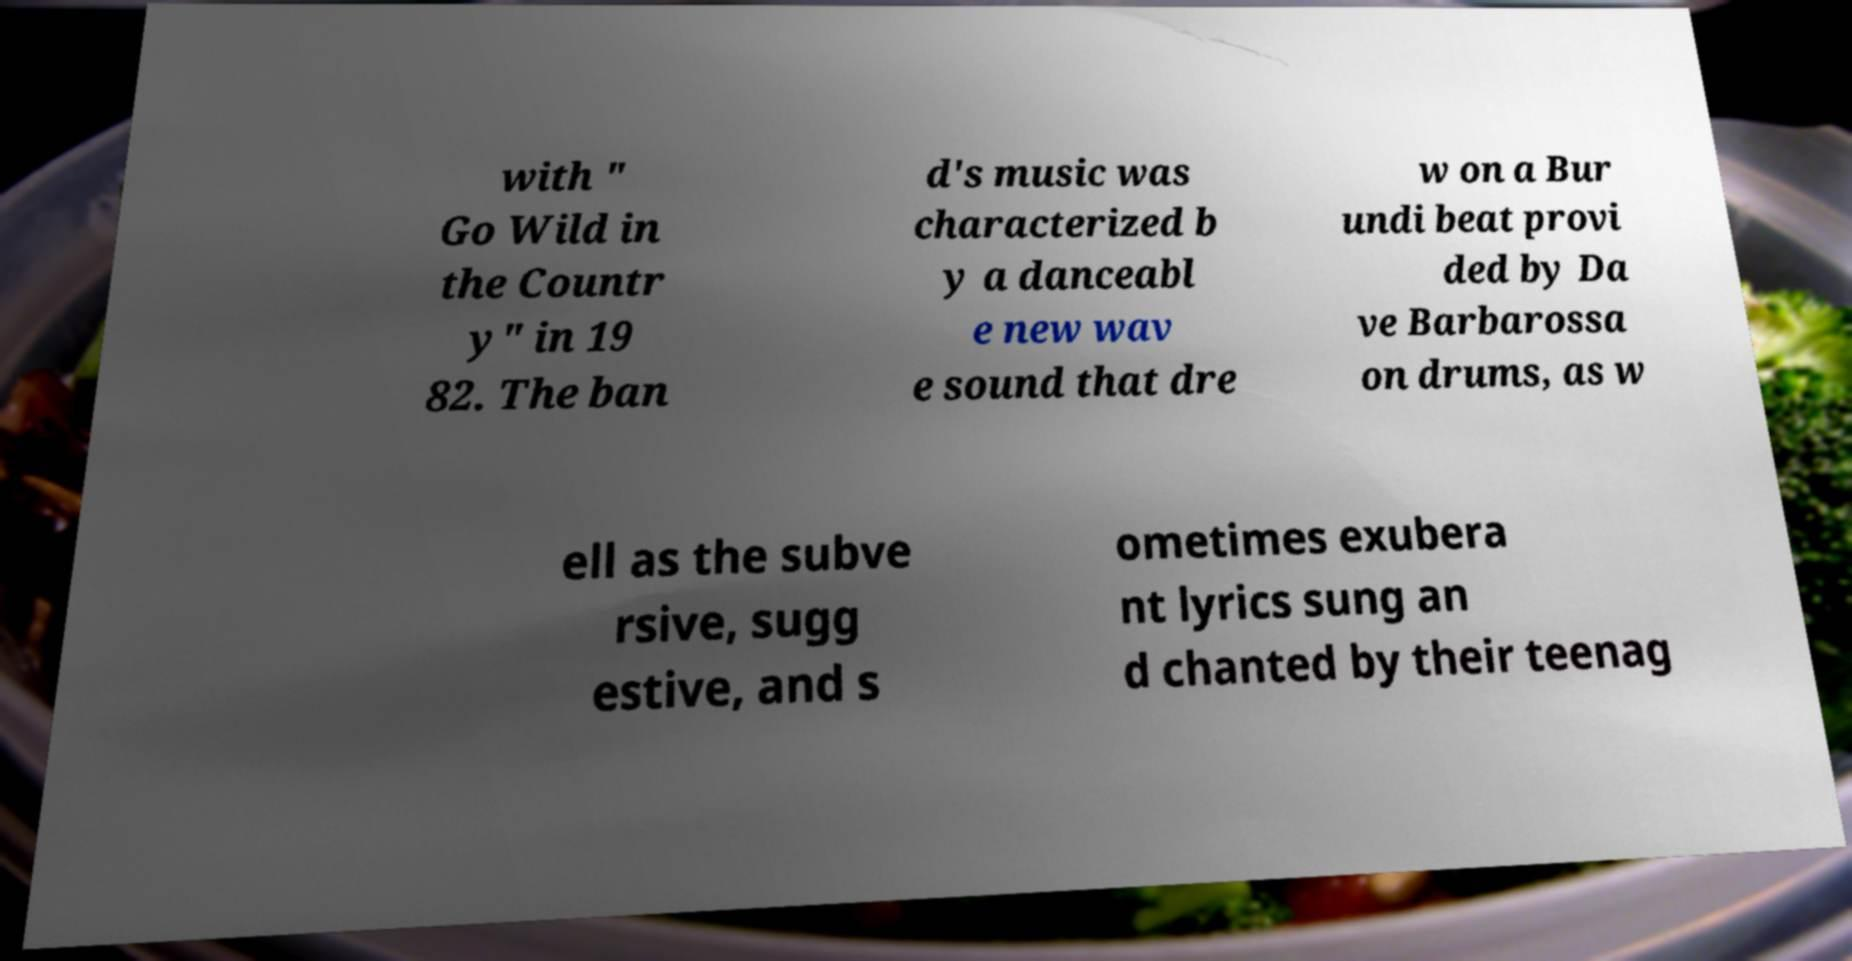Please identify and transcribe the text found in this image. with " Go Wild in the Countr y" in 19 82. The ban d's music was characterized b y a danceabl e new wav e sound that dre w on a Bur undi beat provi ded by Da ve Barbarossa on drums, as w ell as the subve rsive, sugg estive, and s ometimes exubera nt lyrics sung an d chanted by their teenag 